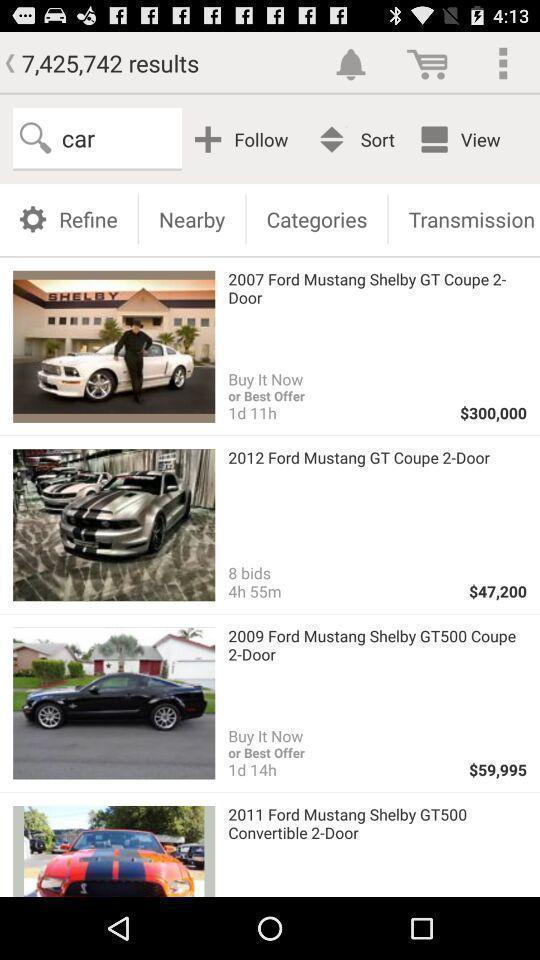Tell me what you see in this picture. Screen showing car models with prices. 